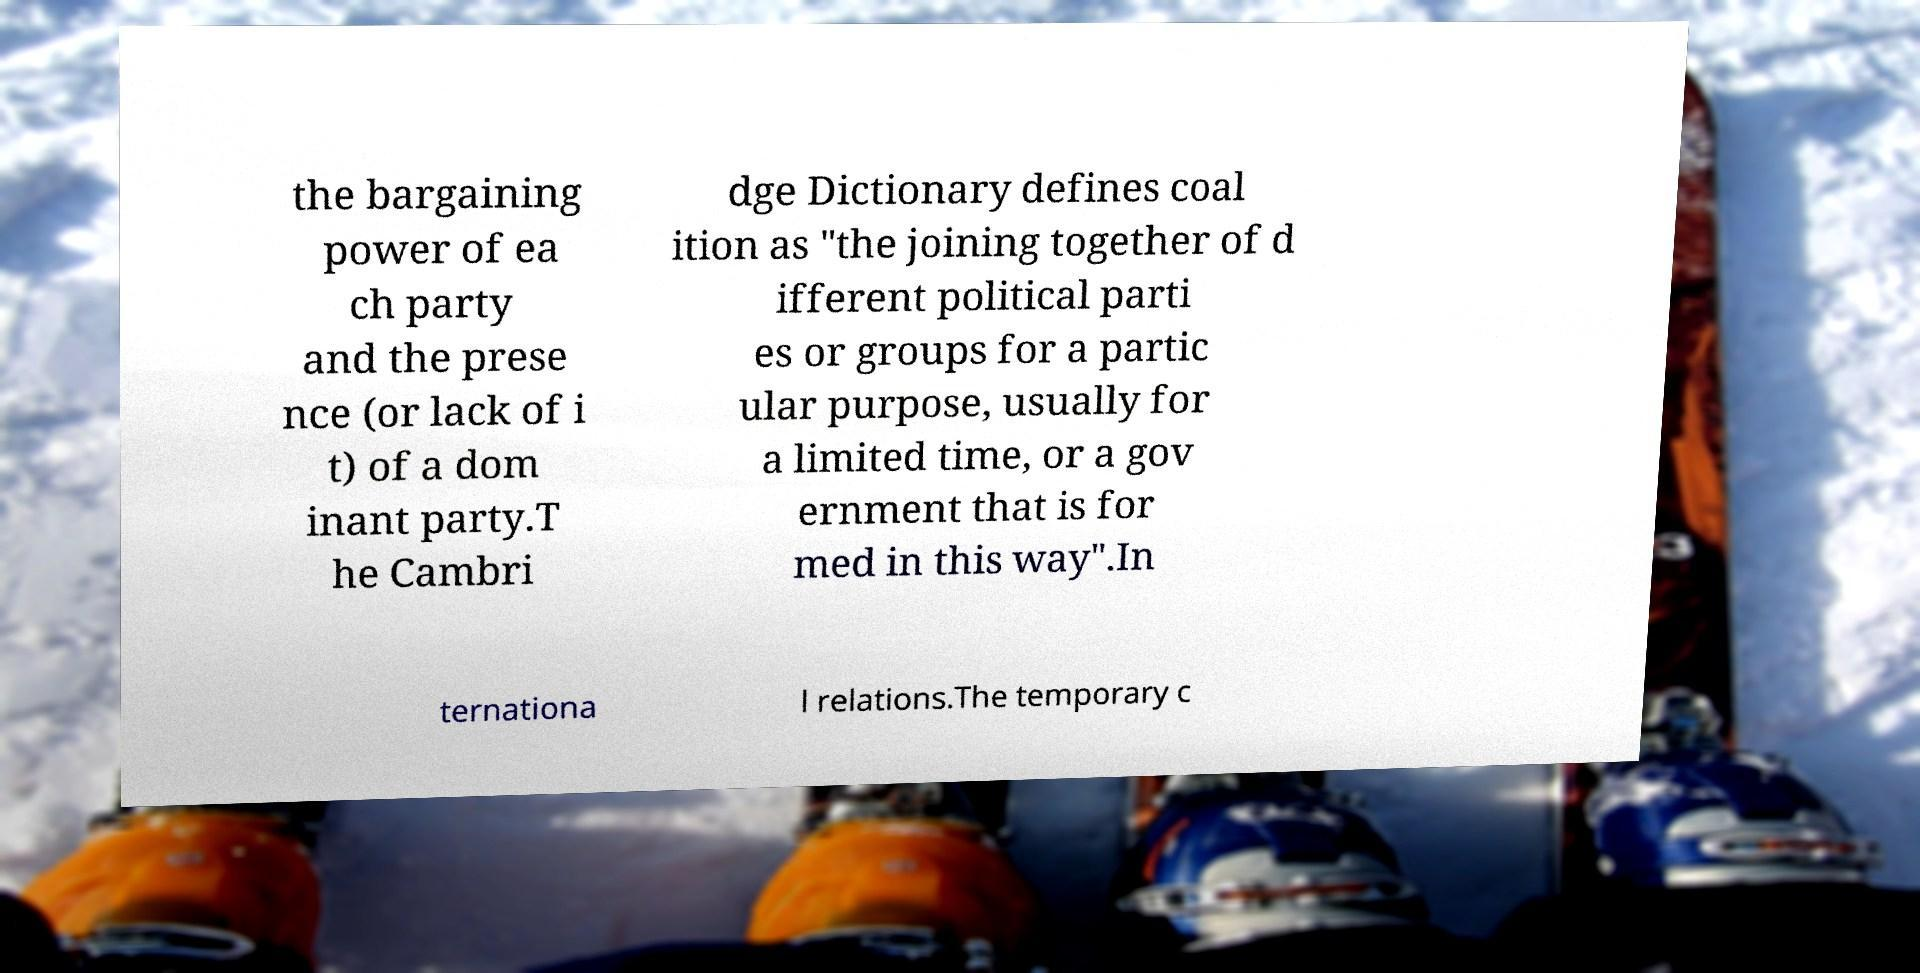Could you extract and type out the text from this image? the bargaining power of ea ch party and the prese nce (or lack of i t) of a dom inant party.T he Cambri dge Dictionary defines coal ition as "the joining together of d ifferent political parti es or groups for a partic ular purpose, usually for a limited time, or a gov ernment that is for med in this way".In ternationa l relations.The temporary c 